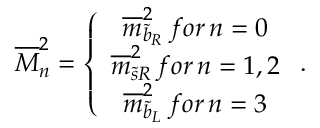<formula> <loc_0><loc_0><loc_500><loc_500>\overline { M } _ { n } ^ { 2 } = \left \{ \begin{array} { c } { { \overline { m } _ { \widetilde { b } _ { R } } ^ { 2 } \, f o r \, n = 0 } } \\ { { \overline { m } _ { \widetilde { s } R } ^ { 2 } \, f o r \, n = 1 , 2 } } \\ { { \overline { m } _ { \widetilde { b } _ { L } } ^ { 2 } \, f o r \, n = 3 } } \end{array} .</formula> 